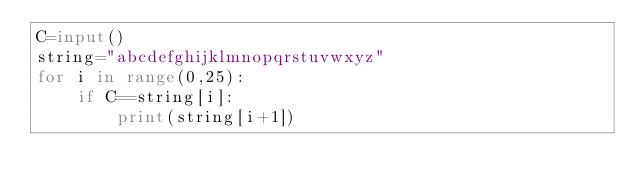<code> <loc_0><loc_0><loc_500><loc_500><_Python_>C=input()
string="abcdefghijklmnopqrstuvwxyz"
for i in range(0,25):
    if C==string[i]:
        print(string[i+1])
</code> 